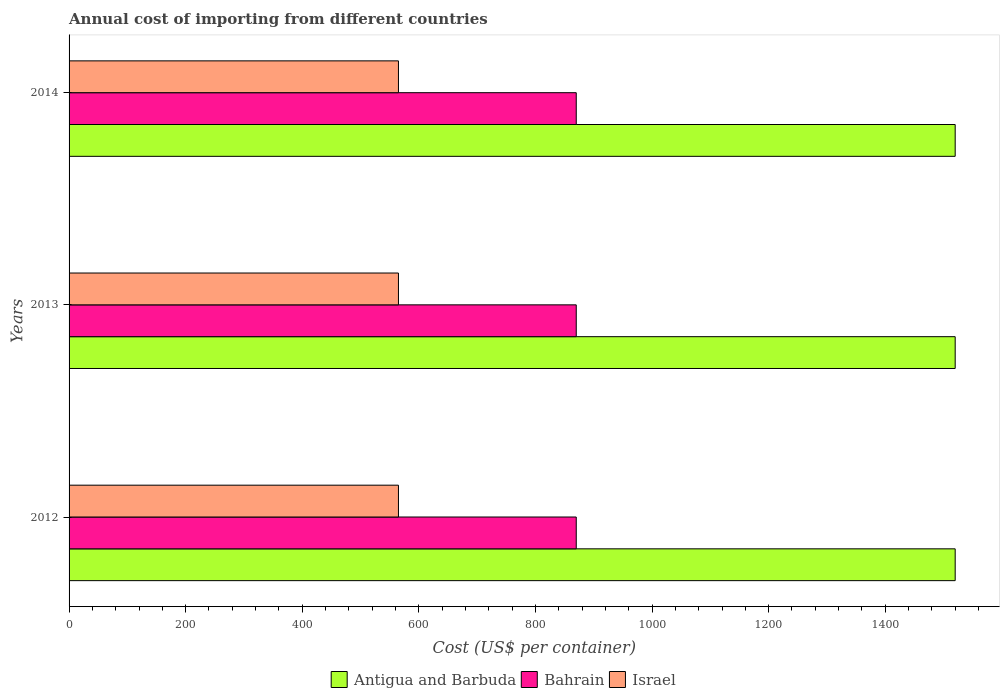Are the number of bars on each tick of the Y-axis equal?
Provide a succinct answer. Yes. In how many cases, is the number of bars for a given year not equal to the number of legend labels?
Provide a succinct answer. 0. What is the total annual cost of importing in Bahrain in 2014?
Give a very brief answer. 870. Across all years, what is the maximum total annual cost of importing in Antigua and Barbuda?
Offer a very short reply. 1520. Across all years, what is the minimum total annual cost of importing in Bahrain?
Your answer should be very brief. 870. In which year was the total annual cost of importing in Israel maximum?
Provide a succinct answer. 2012. What is the total total annual cost of importing in Bahrain in the graph?
Provide a short and direct response. 2610. What is the difference between the total annual cost of importing in Bahrain in 2014 and the total annual cost of importing in Israel in 2012?
Your answer should be very brief. 305. What is the average total annual cost of importing in Israel per year?
Your answer should be compact. 565. In the year 2013, what is the difference between the total annual cost of importing in Antigua and Barbuda and total annual cost of importing in Bahrain?
Make the answer very short. 650. In how many years, is the total annual cost of importing in Bahrain greater than 200 US$?
Provide a short and direct response. 3. What is the ratio of the total annual cost of importing in Bahrain in 2012 to that in 2013?
Your answer should be very brief. 1. What does the 1st bar from the top in 2014 represents?
Ensure brevity in your answer.  Israel. What does the 2nd bar from the bottom in 2012 represents?
Keep it short and to the point. Bahrain. Is it the case that in every year, the sum of the total annual cost of importing in Bahrain and total annual cost of importing in Antigua and Barbuda is greater than the total annual cost of importing in Israel?
Provide a short and direct response. Yes. How many bars are there?
Provide a succinct answer. 9. What is the difference between two consecutive major ticks on the X-axis?
Your answer should be very brief. 200. Are the values on the major ticks of X-axis written in scientific E-notation?
Your response must be concise. No. Does the graph contain any zero values?
Keep it short and to the point. No. Does the graph contain grids?
Your response must be concise. No. Where does the legend appear in the graph?
Keep it short and to the point. Bottom center. What is the title of the graph?
Offer a terse response. Annual cost of importing from different countries. What is the label or title of the X-axis?
Ensure brevity in your answer.  Cost (US$ per container). What is the label or title of the Y-axis?
Provide a short and direct response. Years. What is the Cost (US$ per container) in Antigua and Barbuda in 2012?
Give a very brief answer. 1520. What is the Cost (US$ per container) of Bahrain in 2012?
Give a very brief answer. 870. What is the Cost (US$ per container) in Israel in 2012?
Provide a succinct answer. 565. What is the Cost (US$ per container) in Antigua and Barbuda in 2013?
Your response must be concise. 1520. What is the Cost (US$ per container) of Bahrain in 2013?
Provide a short and direct response. 870. What is the Cost (US$ per container) of Israel in 2013?
Keep it short and to the point. 565. What is the Cost (US$ per container) of Antigua and Barbuda in 2014?
Provide a short and direct response. 1520. What is the Cost (US$ per container) of Bahrain in 2014?
Offer a terse response. 870. What is the Cost (US$ per container) of Israel in 2014?
Offer a terse response. 565. Across all years, what is the maximum Cost (US$ per container) in Antigua and Barbuda?
Provide a short and direct response. 1520. Across all years, what is the maximum Cost (US$ per container) in Bahrain?
Your answer should be very brief. 870. Across all years, what is the maximum Cost (US$ per container) in Israel?
Keep it short and to the point. 565. Across all years, what is the minimum Cost (US$ per container) in Antigua and Barbuda?
Your answer should be compact. 1520. Across all years, what is the minimum Cost (US$ per container) of Bahrain?
Keep it short and to the point. 870. Across all years, what is the minimum Cost (US$ per container) of Israel?
Make the answer very short. 565. What is the total Cost (US$ per container) of Antigua and Barbuda in the graph?
Keep it short and to the point. 4560. What is the total Cost (US$ per container) of Bahrain in the graph?
Your answer should be compact. 2610. What is the total Cost (US$ per container) of Israel in the graph?
Your answer should be compact. 1695. What is the difference between the Cost (US$ per container) of Antigua and Barbuda in 2012 and that in 2013?
Keep it short and to the point. 0. What is the difference between the Cost (US$ per container) in Bahrain in 2012 and that in 2013?
Your response must be concise. 0. What is the difference between the Cost (US$ per container) in Israel in 2012 and that in 2013?
Offer a terse response. 0. What is the difference between the Cost (US$ per container) of Antigua and Barbuda in 2012 and that in 2014?
Your response must be concise. 0. What is the difference between the Cost (US$ per container) in Israel in 2012 and that in 2014?
Keep it short and to the point. 0. What is the difference between the Cost (US$ per container) of Antigua and Barbuda in 2012 and the Cost (US$ per container) of Bahrain in 2013?
Your answer should be compact. 650. What is the difference between the Cost (US$ per container) of Antigua and Barbuda in 2012 and the Cost (US$ per container) of Israel in 2013?
Provide a succinct answer. 955. What is the difference between the Cost (US$ per container) in Bahrain in 2012 and the Cost (US$ per container) in Israel in 2013?
Provide a short and direct response. 305. What is the difference between the Cost (US$ per container) of Antigua and Barbuda in 2012 and the Cost (US$ per container) of Bahrain in 2014?
Provide a succinct answer. 650. What is the difference between the Cost (US$ per container) in Antigua and Barbuda in 2012 and the Cost (US$ per container) in Israel in 2014?
Ensure brevity in your answer.  955. What is the difference between the Cost (US$ per container) of Bahrain in 2012 and the Cost (US$ per container) of Israel in 2014?
Give a very brief answer. 305. What is the difference between the Cost (US$ per container) in Antigua and Barbuda in 2013 and the Cost (US$ per container) in Bahrain in 2014?
Offer a terse response. 650. What is the difference between the Cost (US$ per container) of Antigua and Barbuda in 2013 and the Cost (US$ per container) of Israel in 2014?
Your answer should be very brief. 955. What is the difference between the Cost (US$ per container) in Bahrain in 2013 and the Cost (US$ per container) in Israel in 2014?
Provide a succinct answer. 305. What is the average Cost (US$ per container) in Antigua and Barbuda per year?
Give a very brief answer. 1520. What is the average Cost (US$ per container) of Bahrain per year?
Provide a succinct answer. 870. What is the average Cost (US$ per container) of Israel per year?
Your response must be concise. 565. In the year 2012, what is the difference between the Cost (US$ per container) of Antigua and Barbuda and Cost (US$ per container) of Bahrain?
Provide a succinct answer. 650. In the year 2012, what is the difference between the Cost (US$ per container) of Antigua and Barbuda and Cost (US$ per container) of Israel?
Keep it short and to the point. 955. In the year 2012, what is the difference between the Cost (US$ per container) of Bahrain and Cost (US$ per container) of Israel?
Make the answer very short. 305. In the year 2013, what is the difference between the Cost (US$ per container) of Antigua and Barbuda and Cost (US$ per container) of Bahrain?
Offer a terse response. 650. In the year 2013, what is the difference between the Cost (US$ per container) in Antigua and Barbuda and Cost (US$ per container) in Israel?
Offer a very short reply. 955. In the year 2013, what is the difference between the Cost (US$ per container) in Bahrain and Cost (US$ per container) in Israel?
Give a very brief answer. 305. In the year 2014, what is the difference between the Cost (US$ per container) in Antigua and Barbuda and Cost (US$ per container) in Bahrain?
Your answer should be very brief. 650. In the year 2014, what is the difference between the Cost (US$ per container) in Antigua and Barbuda and Cost (US$ per container) in Israel?
Your answer should be compact. 955. In the year 2014, what is the difference between the Cost (US$ per container) in Bahrain and Cost (US$ per container) in Israel?
Provide a succinct answer. 305. What is the ratio of the Cost (US$ per container) in Antigua and Barbuda in 2012 to that in 2013?
Keep it short and to the point. 1. What is the ratio of the Cost (US$ per container) of Bahrain in 2012 to that in 2013?
Offer a terse response. 1. What is the ratio of the Cost (US$ per container) of Bahrain in 2013 to that in 2014?
Give a very brief answer. 1. What is the ratio of the Cost (US$ per container) of Israel in 2013 to that in 2014?
Keep it short and to the point. 1. What is the difference between the highest and the second highest Cost (US$ per container) in Antigua and Barbuda?
Provide a succinct answer. 0. What is the difference between the highest and the second highest Cost (US$ per container) in Bahrain?
Make the answer very short. 0. What is the difference between the highest and the second highest Cost (US$ per container) of Israel?
Keep it short and to the point. 0. 